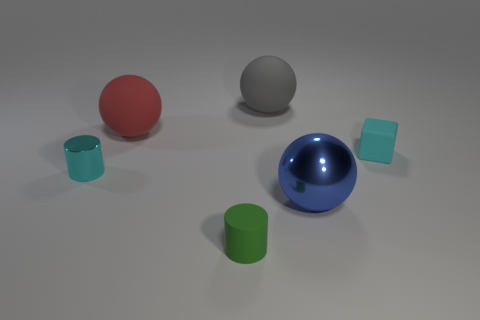What colors can you see in the image? The image features a variety of colors. There is a red sphere, a dull gray sphere, a shiny blue sphere, and two green cylindrical objects. Additionally, there are two small aqua-colored cubes. Which object stands out the most to you? The shiny blue sphere stands out the most. Its glossy texture and vibrant color catch the eye amidst the other objects with more matte finishes. 